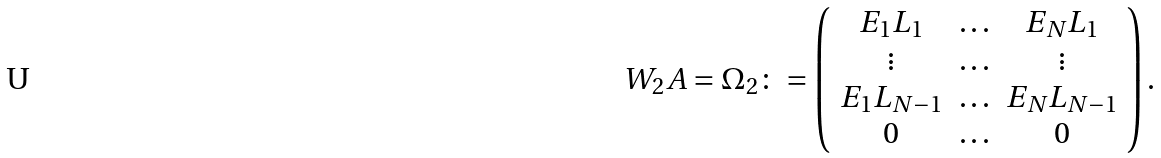Convert formula to latex. <formula><loc_0><loc_0><loc_500><loc_500>W _ { 2 } A = \Omega _ { 2 } \colon = \left ( \begin{array} { c c c } E _ { 1 } L _ { 1 } & \hdots & E _ { N } L _ { 1 } \\ \vdots & \hdots & \vdots \\ E _ { 1 } L _ { N - 1 } & \hdots & E _ { N } L _ { N - 1 } \\ 0 & \hdots & 0 \\ \end{array} \right ) .</formula> 